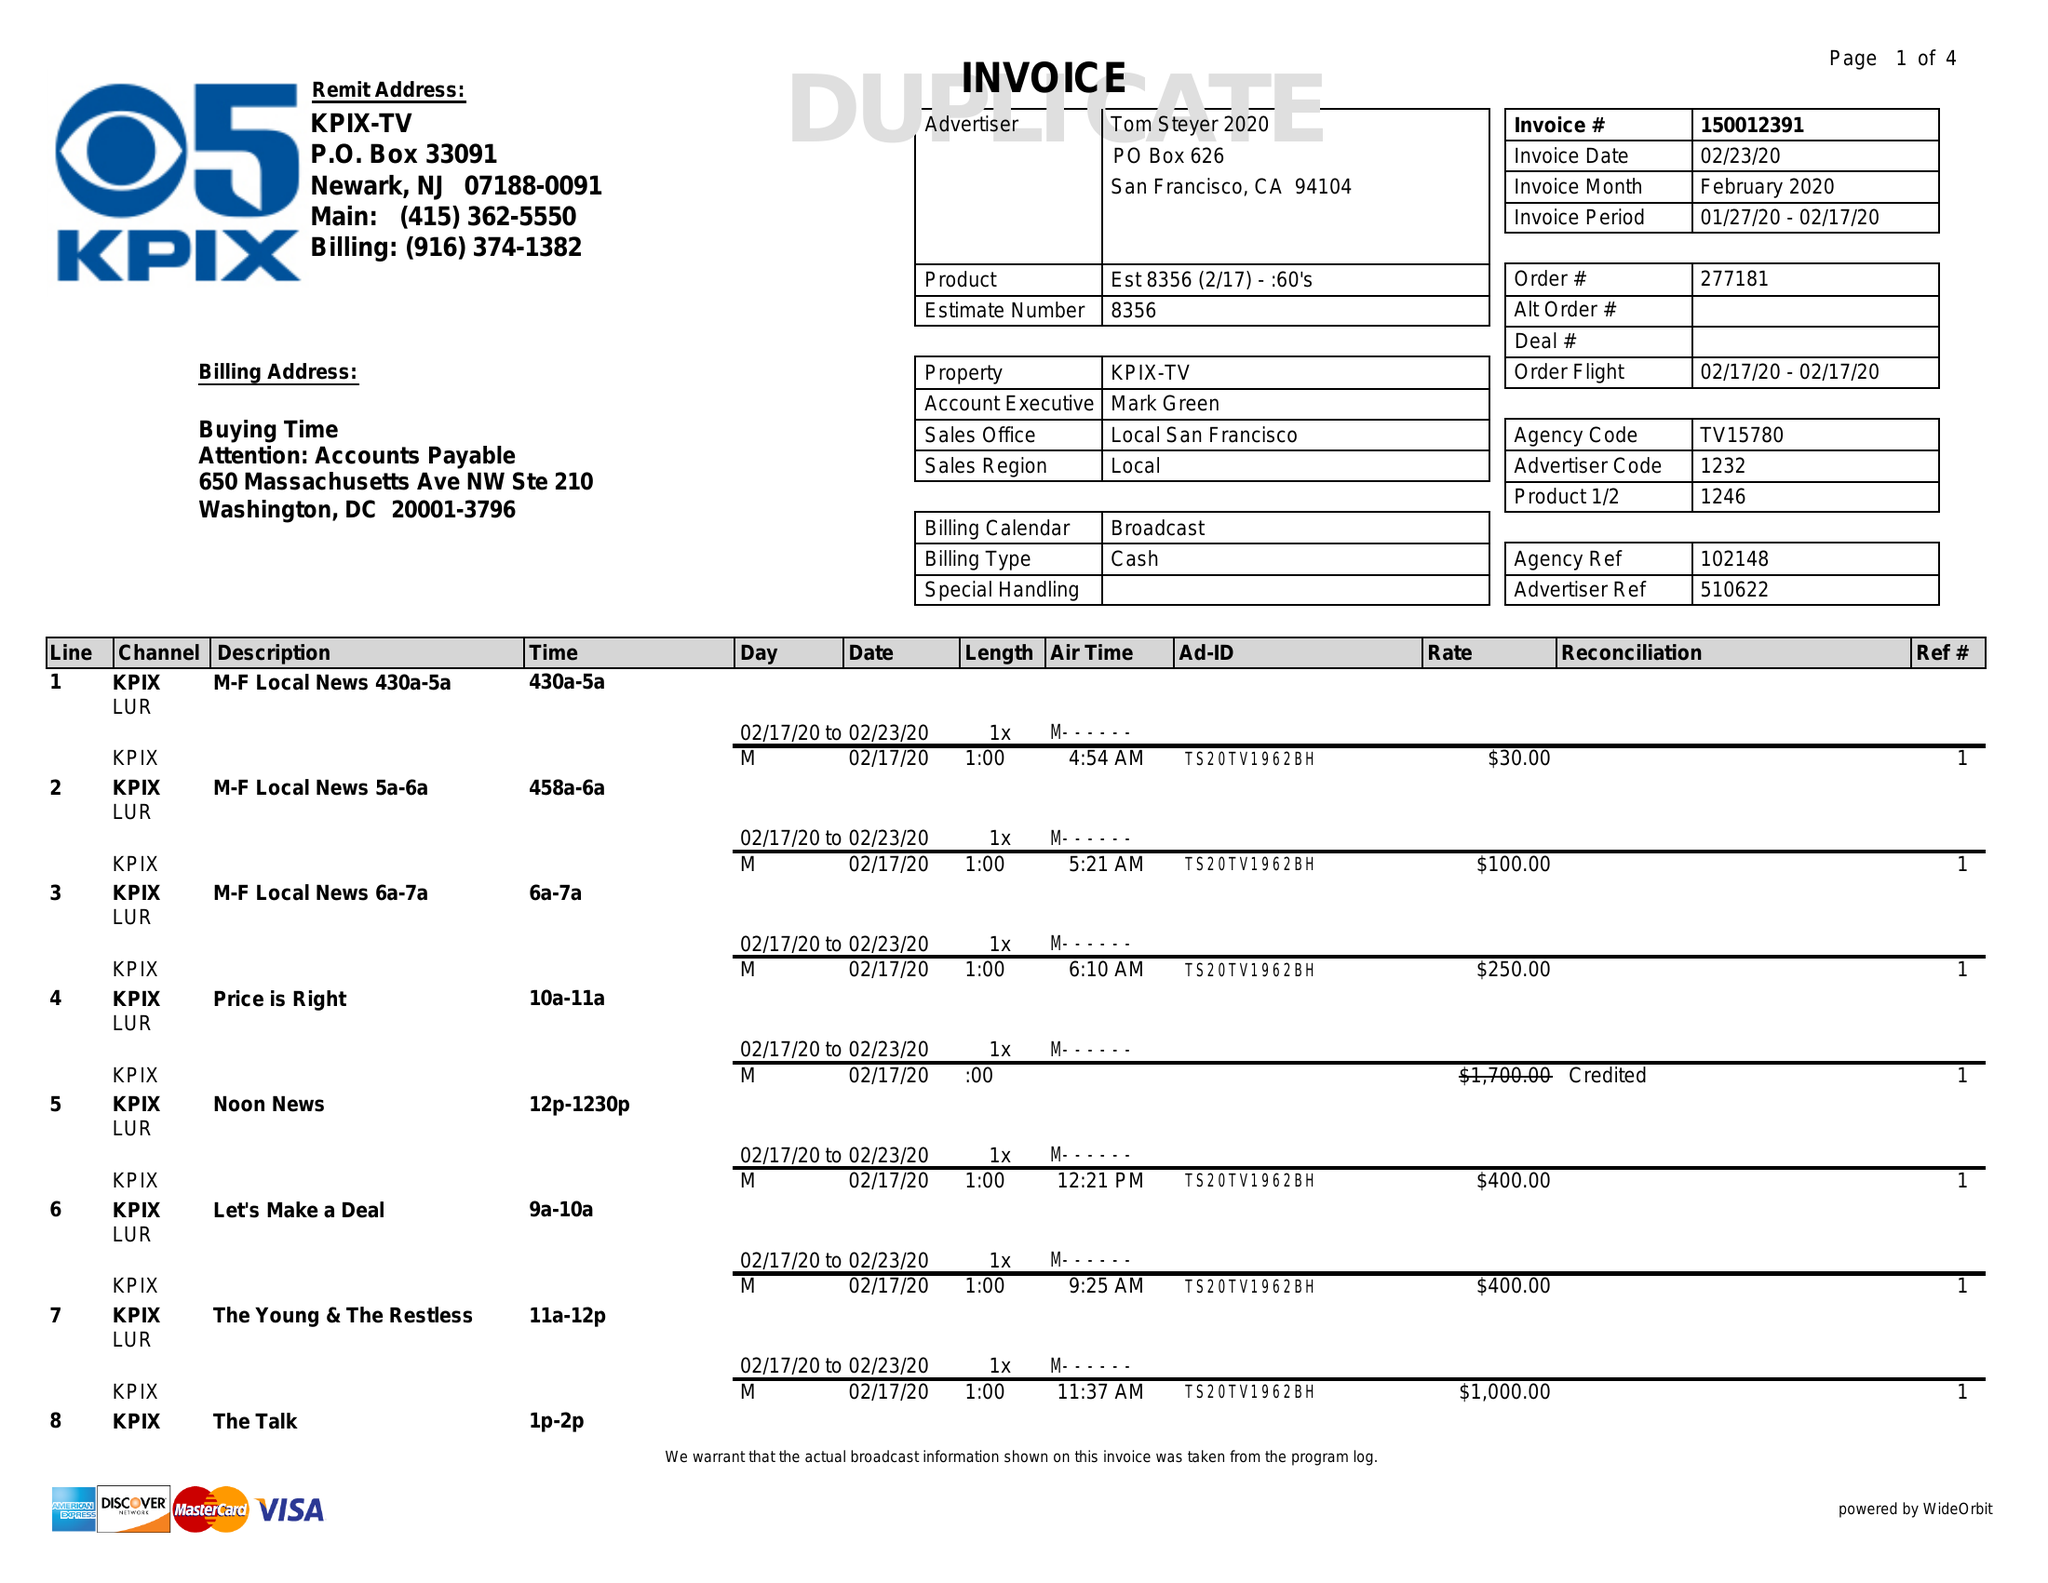What is the value for the gross_amount?
Answer the question using a single word or phrase. 31580.00 